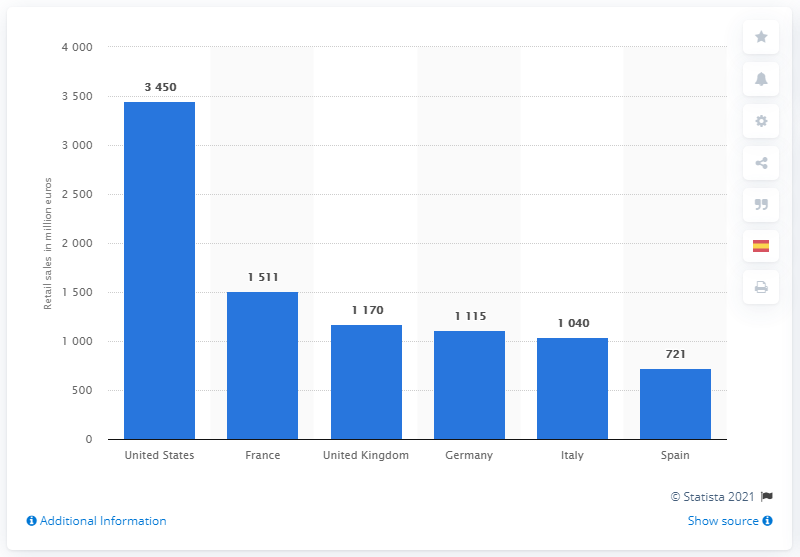Give some essential details in this illustration. In 2013, the value of the German frame market for eyewear was 1,115. 